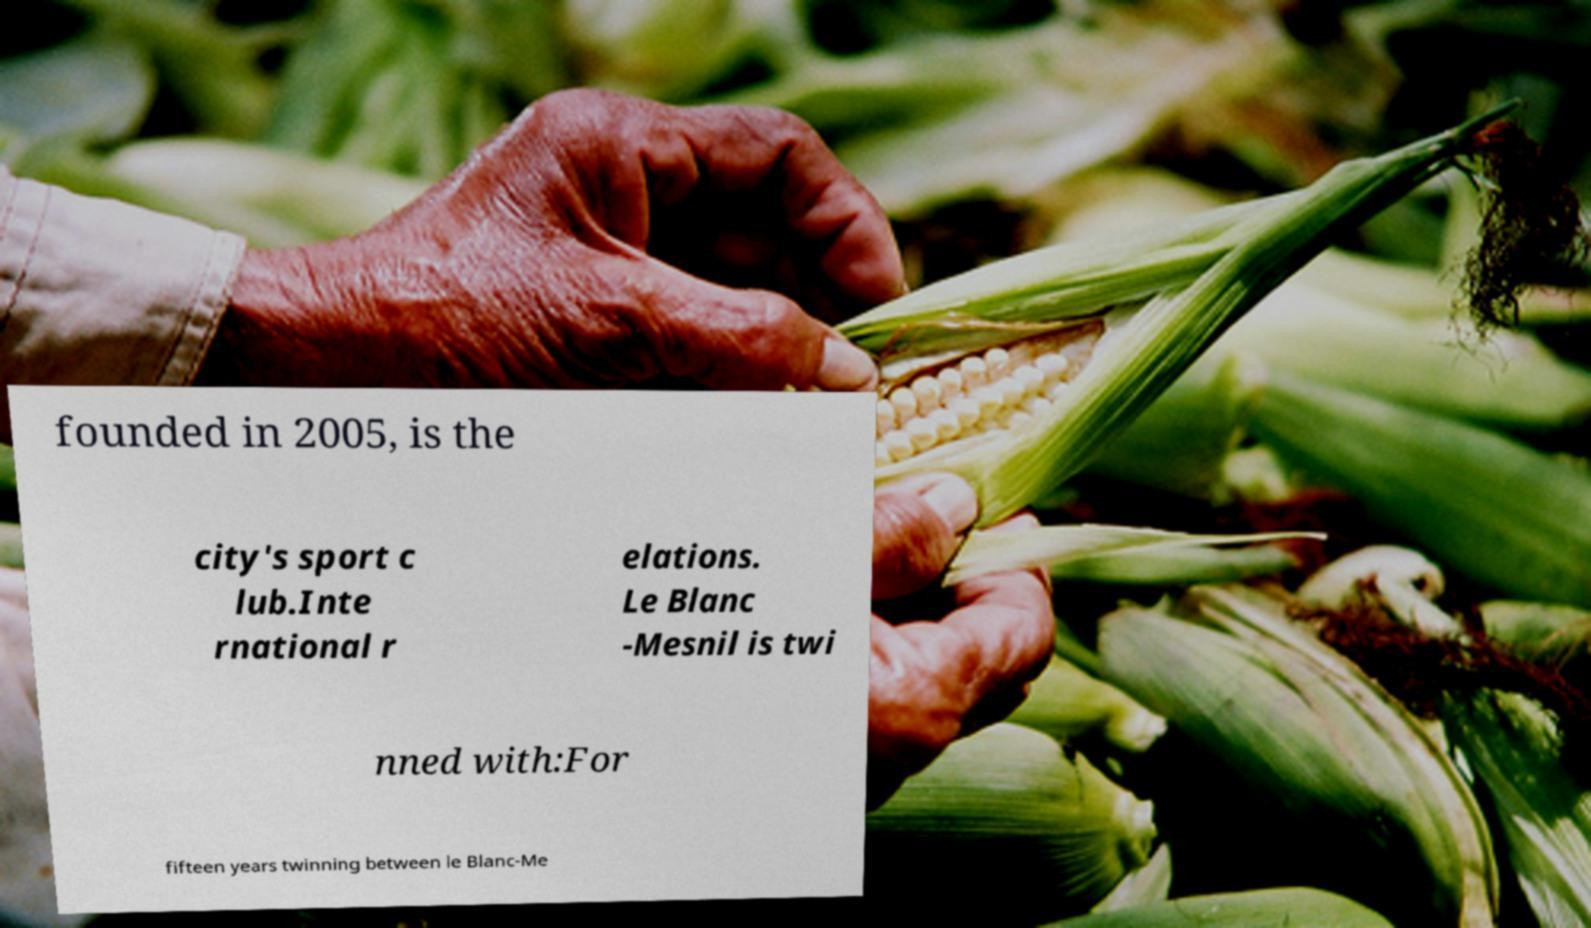There's text embedded in this image that I need extracted. Can you transcribe it verbatim? founded in 2005, is the city's sport c lub.Inte rnational r elations. Le Blanc -Mesnil is twi nned with:For fifteen years twinning between le Blanc-Me 